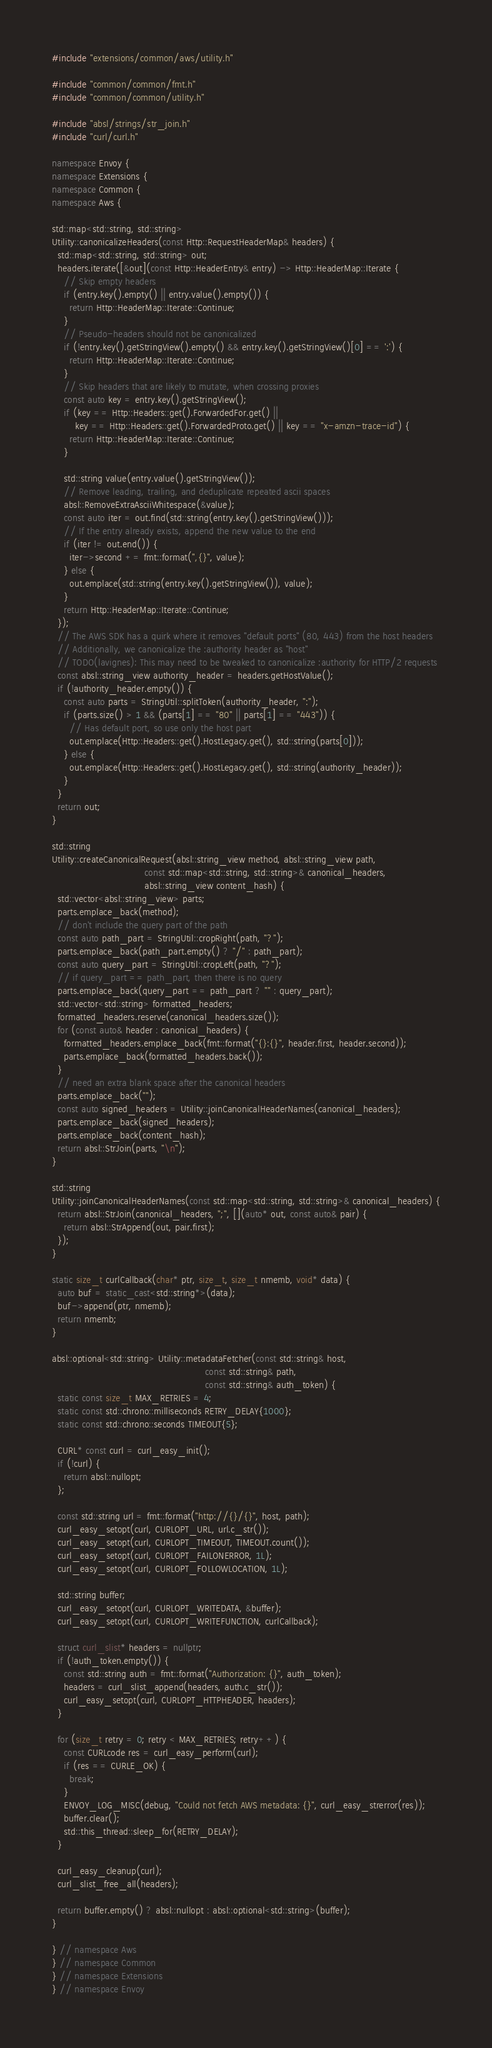<code> <loc_0><loc_0><loc_500><loc_500><_C++_>#include "extensions/common/aws/utility.h"

#include "common/common/fmt.h"
#include "common/common/utility.h"

#include "absl/strings/str_join.h"
#include "curl/curl.h"

namespace Envoy {
namespace Extensions {
namespace Common {
namespace Aws {

std::map<std::string, std::string>
Utility::canonicalizeHeaders(const Http::RequestHeaderMap& headers) {
  std::map<std::string, std::string> out;
  headers.iterate([&out](const Http::HeaderEntry& entry) -> Http::HeaderMap::Iterate {
    // Skip empty headers
    if (entry.key().empty() || entry.value().empty()) {
      return Http::HeaderMap::Iterate::Continue;
    }
    // Pseudo-headers should not be canonicalized
    if (!entry.key().getStringView().empty() && entry.key().getStringView()[0] == ':') {
      return Http::HeaderMap::Iterate::Continue;
    }
    // Skip headers that are likely to mutate, when crossing proxies
    const auto key = entry.key().getStringView();
    if (key == Http::Headers::get().ForwardedFor.get() ||
        key == Http::Headers::get().ForwardedProto.get() || key == "x-amzn-trace-id") {
      return Http::HeaderMap::Iterate::Continue;
    }

    std::string value(entry.value().getStringView());
    // Remove leading, trailing, and deduplicate repeated ascii spaces
    absl::RemoveExtraAsciiWhitespace(&value);
    const auto iter = out.find(std::string(entry.key().getStringView()));
    // If the entry already exists, append the new value to the end
    if (iter != out.end()) {
      iter->second += fmt::format(",{}", value);
    } else {
      out.emplace(std::string(entry.key().getStringView()), value);
    }
    return Http::HeaderMap::Iterate::Continue;
  });
  // The AWS SDK has a quirk where it removes "default ports" (80, 443) from the host headers
  // Additionally, we canonicalize the :authority header as "host"
  // TODO(lavignes): This may need to be tweaked to canonicalize :authority for HTTP/2 requests
  const absl::string_view authority_header = headers.getHostValue();
  if (!authority_header.empty()) {
    const auto parts = StringUtil::splitToken(authority_header, ":");
    if (parts.size() > 1 && (parts[1] == "80" || parts[1] == "443")) {
      // Has default port, so use only the host part
      out.emplace(Http::Headers::get().HostLegacy.get(), std::string(parts[0]));
    } else {
      out.emplace(Http::Headers::get().HostLegacy.get(), std::string(authority_header));
    }
  }
  return out;
}

std::string
Utility::createCanonicalRequest(absl::string_view method, absl::string_view path,
                                const std::map<std::string, std::string>& canonical_headers,
                                absl::string_view content_hash) {
  std::vector<absl::string_view> parts;
  parts.emplace_back(method);
  // don't include the query part of the path
  const auto path_part = StringUtil::cropRight(path, "?");
  parts.emplace_back(path_part.empty() ? "/" : path_part);
  const auto query_part = StringUtil::cropLeft(path, "?");
  // if query_part == path_part, then there is no query
  parts.emplace_back(query_part == path_part ? "" : query_part);
  std::vector<std::string> formatted_headers;
  formatted_headers.reserve(canonical_headers.size());
  for (const auto& header : canonical_headers) {
    formatted_headers.emplace_back(fmt::format("{}:{}", header.first, header.second));
    parts.emplace_back(formatted_headers.back());
  }
  // need an extra blank space after the canonical headers
  parts.emplace_back("");
  const auto signed_headers = Utility::joinCanonicalHeaderNames(canonical_headers);
  parts.emplace_back(signed_headers);
  parts.emplace_back(content_hash);
  return absl::StrJoin(parts, "\n");
}

std::string
Utility::joinCanonicalHeaderNames(const std::map<std::string, std::string>& canonical_headers) {
  return absl::StrJoin(canonical_headers, ";", [](auto* out, const auto& pair) {
    return absl::StrAppend(out, pair.first);
  });
}

static size_t curlCallback(char* ptr, size_t, size_t nmemb, void* data) {
  auto buf = static_cast<std::string*>(data);
  buf->append(ptr, nmemb);
  return nmemb;
}

absl::optional<std::string> Utility::metadataFetcher(const std::string& host,
                                                     const std::string& path,
                                                     const std::string& auth_token) {
  static const size_t MAX_RETRIES = 4;
  static const std::chrono::milliseconds RETRY_DELAY{1000};
  static const std::chrono::seconds TIMEOUT{5};

  CURL* const curl = curl_easy_init();
  if (!curl) {
    return absl::nullopt;
  };

  const std::string url = fmt::format("http://{}/{}", host, path);
  curl_easy_setopt(curl, CURLOPT_URL, url.c_str());
  curl_easy_setopt(curl, CURLOPT_TIMEOUT, TIMEOUT.count());
  curl_easy_setopt(curl, CURLOPT_FAILONERROR, 1L);
  curl_easy_setopt(curl, CURLOPT_FOLLOWLOCATION, 1L);

  std::string buffer;
  curl_easy_setopt(curl, CURLOPT_WRITEDATA, &buffer);
  curl_easy_setopt(curl, CURLOPT_WRITEFUNCTION, curlCallback);

  struct curl_slist* headers = nullptr;
  if (!auth_token.empty()) {
    const std::string auth = fmt::format("Authorization: {}", auth_token);
    headers = curl_slist_append(headers, auth.c_str());
    curl_easy_setopt(curl, CURLOPT_HTTPHEADER, headers);
  }

  for (size_t retry = 0; retry < MAX_RETRIES; retry++) {
    const CURLcode res = curl_easy_perform(curl);
    if (res == CURLE_OK) {
      break;
    }
    ENVOY_LOG_MISC(debug, "Could not fetch AWS metadata: {}", curl_easy_strerror(res));
    buffer.clear();
    std::this_thread::sleep_for(RETRY_DELAY);
  }

  curl_easy_cleanup(curl);
  curl_slist_free_all(headers);

  return buffer.empty() ? absl::nullopt : absl::optional<std::string>(buffer);
}

} // namespace Aws
} // namespace Common
} // namespace Extensions
} // namespace Envoy
</code> 